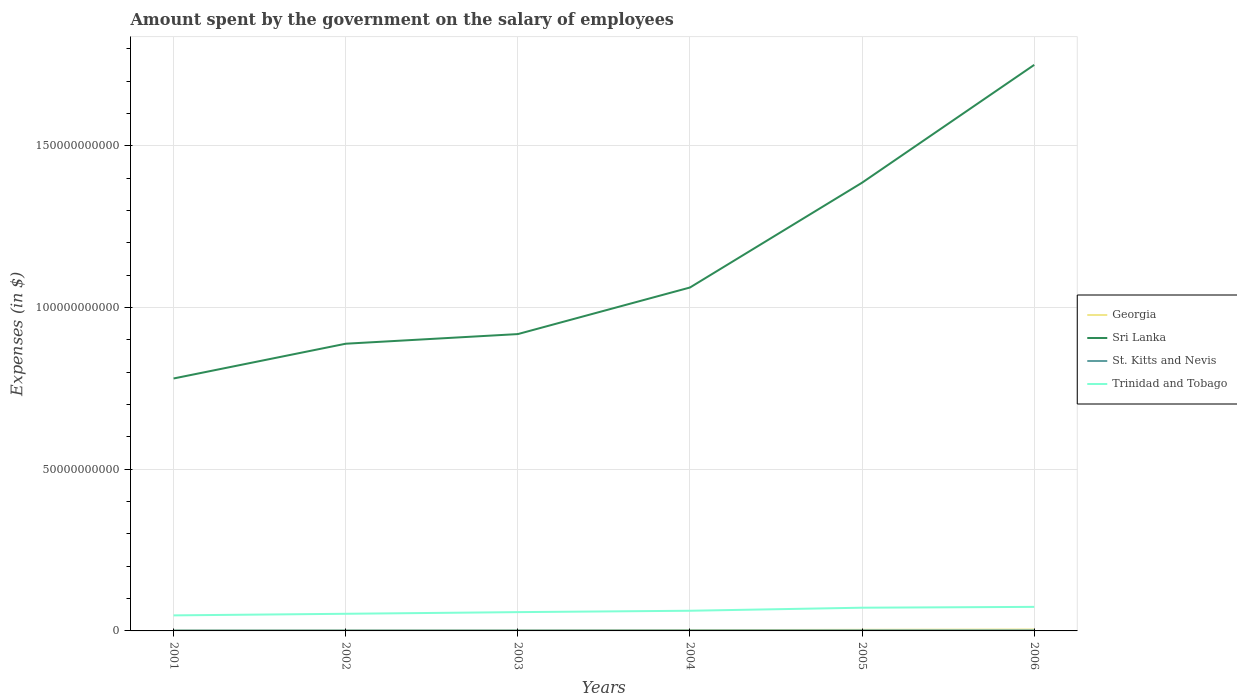Across all years, what is the maximum amount spent on the salary of employees by the government in Trinidad and Tobago?
Keep it short and to the point. 4.81e+09. What is the total amount spent on the salary of employees by the government in Sri Lanka in the graph?
Give a very brief answer. -4.98e+1. What is the difference between the highest and the second highest amount spent on the salary of employees by the government in Sri Lanka?
Your response must be concise. 9.70e+1. Is the amount spent on the salary of employees by the government in Sri Lanka strictly greater than the amount spent on the salary of employees by the government in Trinidad and Tobago over the years?
Make the answer very short. No. How many years are there in the graph?
Provide a short and direct response. 6. What is the title of the graph?
Make the answer very short. Amount spent by the government on the salary of employees. What is the label or title of the X-axis?
Your answer should be compact. Years. What is the label or title of the Y-axis?
Your answer should be compact. Expenses (in $). What is the Expenses (in $) of Georgia in 2001?
Ensure brevity in your answer.  9.74e+07. What is the Expenses (in $) in Sri Lanka in 2001?
Your answer should be very brief. 7.81e+1. What is the Expenses (in $) in St. Kitts and Nevis in 2001?
Give a very brief answer. 1.40e+08. What is the Expenses (in $) of Trinidad and Tobago in 2001?
Make the answer very short. 4.81e+09. What is the Expenses (in $) of Georgia in 2002?
Keep it short and to the point. 1.12e+08. What is the Expenses (in $) of Sri Lanka in 2002?
Provide a succinct answer. 8.88e+1. What is the Expenses (in $) of St. Kitts and Nevis in 2002?
Your response must be concise. 1.44e+08. What is the Expenses (in $) of Trinidad and Tobago in 2002?
Provide a succinct answer. 5.30e+09. What is the Expenses (in $) in Georgia in 2003?
Make the answer very short. 1.32e+08. What is the Expenses (in $) in Sri Lanka in 2003?
Ensure brevity in your answer.  9.18e+1. What is the Expenses (in $) of St. Kitts and Nevis in 2003?
Make the answer very short. 1.44e+08. What is the Expenses (in $) in Trinidad and Tobago in 2003?
Give a very brief answer. 5.81e+09. What is the Expenses (in $) in Georgia in 2004?
Your answer should be compact. 2.33e+08. What is the Expenses (in $) of Sri Lanka in 2004?
Make the answer very short. 1.06e+11. What is the Expenses (in $) in St. Kitts and Nevis in 2004?
Your response must be concise. 1.60e+08. What is the Expenses (in $) of Trinidad and Tobago in 2004?
Provide a short and direct response. 6.24e+09. What is the Expenses (in $) in Georgia in 2005?
Your response must be concise. 3.37e+08. What is the Expenses (in $) in Sri Lanka in 2005?
Ensure brevity in your answer.  1.39e+11. What is the Expenses (in $) of St. Kitts and Nevis in 2005?
Offer a terse response. 1.63e+08. What is the Expenses (in $) of Trinidad and Tobago in 2005?
Keep it short and to the point. 7.18e+09. What is the Expenses (in $) in Georgia in 2006?
Your answer should be very brief. 4.52e+08. What is the Expenses (in $) in Sri Lanka in 2006?
Ensure brevity in your answer.  1.75e+11. What is the Expenses (in $) of St. Kitts and Nevis in 2006?
Offer a terse response. 1.70e+08. What is the Expenses (in $) of Trinidad and Tobago in 2006?
Provide a short and direct response. 7.43e+09. Across all years, what is the maximum Expenses (in $) in Georgia?
Your answer should be compact. 4.52e+08. Across all years, what is the maximum Expenses (in $) of Sri Lanka?
Offer a terse response. 1.75e+11. Across all years, what is the maximum Expenses (in $) of St. Kitts and Nevis?
Provide a succinct answer. 1.70e+08. Across all years, what is the maximum Expenses (in $) of Trinidad and Tobago?
Your answer should be very brief. 7.43e+09. Across all years, what is the minimum Expenses (in $) in Georgia?
Offer a terse response. 9.74e+07. Across all years, what is the minimum Expenses (in $) in Sri Lanka?
Ensure brevity in your answer.  7.81e+1. Across all years, what is the minimum Expenses (in $) of St. Kitts and Nevis?
Your answer should be compact. 1.40e+08. Across all years, what is the minimum Expenses (in $) in Trinidad and Tobago?
Keep it short and to the point. 4.81e+09. What is the total Expenses (in $) in Georgia in the graph?
Offer a terse response. 1.36e+09. What is the total Expenses (in $) in Sri Lanka in the graph?
Your answer should be very brief. 6.78e+11. What is the total Expenses (in $) of St. Kitts and Nevis in the graph?
Offer a terse response. 9.21e+08. What is the total Expenses (in $) of Trinidad and Tobago in the graph?
Offer a terse response. 3.68e+1. What is the difference between the Expenses (in $) in Georgia in 2001 and that in 2002?
Ensure brevity in your answer.  -1.46e+07. What is the difference between the Expenses (in $) in Sri Lanka in 2001 and that in 2002?
Give a very brief answer. -1.07e+1. What is the difference between the Expenses (in $) of St. Kitts and Nevis in 2001 and that in 2002?
Offer a terse response. -3.90e+06. What is the difference between the Expenses (in $) in Trinidad and Tobago in 2001 and that in 2002?
Give a very brief answer. -4.90e+08. What is the difference between the Expenses (in $) of Georgia in 2001 and that in 2003?
Ensure brevity in your answer.  -3.41e+07. What is the difference between the Expenses (in $) of Sri Lanka in 2001 and that in 2003?
Keep it short and to the point. -1.37e+1. What is the difference between the Expenses (in $) of St. Kitts and Nevis in 2001 and that in 2003?
Give a very brief answer. -3.80e+06. What is the difference between the Expenses (in $) in Trinidad and Tobago in 2001 and that in 2003?
Make the answer very short. -1.00e+09. What is the difference between the Expenses (in $) of Georgia in 2001 and that in 2004?
Provide a short and direct response. -1.36e+08. What is the difference between the Expenses (in $) of Sri Lanka in 2001 and that in 2004?
Give a very brief answer. -2.81e+1. What is the difference between the Expenses (in $) in St. Kitts and Nevis in 2001 and that in 2004?
Your answer should be very brief. -1.94e+07. What is the difference between the Expenses (in $) in Trinidad and Tobago in 2001 and that in 2004?
Provide a succinct answer. -1.43e+09. What is the difference between the Expenses (in $) of Georgia in 2001 and that in 2005?
Keep it short and to the point. -2.39e+08. What is the difference between the Expenses (in $) in Sri Lanka in 2001 and that in 2005?
Your answer should be compact. -6.05e+1. What is the difference between the Expenses (in $) in St. Kitts and Nevis in 2001 and that in 2005?
Keep it short and to the point. -2.28e+07. What is the difference between the Expenses (in $) of Trinidad and Tobago in 2001 and that in 2005?
Make the answer very short. -2.37e+09. What is the difference between the Expenses (in $) of Georgia in 2001 and that in 2006?
Your answer should be very brief. -3.54e+08. What is the difference between the Expenses (in $) of Sri Lanka in 2001 and that in 2006?
Provide a short and direct response. -9.70e+1. What is the difference between the Expenses (in $) in St. Kitts and Nevis in 2001 and that in 2006?
Offer a very short reply. -2.92e+07. What is the difference between the Expenses (in $) in Trinidad and Tobago in 2001 and that in 2006?
Give a very brief answer. -2.63e+09. What is the difference between the Expenses (in $) of Georgia in 2002 and that in 2003?
Your response must be concise. -1.95e+07. What is the difference between the Expenses (in $) in Sri Lanka in 2002 and that in 2003?
Your answer should be very brief. -2.98e+09. What is the difference between the Expenses (in $) in Trinidad and Tobago in 2002 and that in 2003?
Your answer should be compact. -5.14e+08. What is the difference between the Expenses (in $) in Georgia in 2002 and that in 2004?
Make the answer very short. -1.21e+08. What is the difference between the Expenses (in $) in Sri Lanka in 2002 and that in 2004?
Give a very brief answer. -1.74e+1. What is the difference between the Expenses (in $) in St. Kitts and Nevis in 2002 and that in 2004?
Offer a terse response. -1.55e+07. What is the difference between the Expenses (in $) of Trinidad and Tobago in 2002 and that in 2004?
Your answer should be compact. -9.40e+08. What is the difference between the Expenses (in $) in Georgia in 2002 and that in 2005?
Your answer should be compact. -2.25e+08. What is the difference between the Expenses (in $) in Sri Lanka in 2002 and that in 2005?
Give a very brief answer. -4.98e+1. What is the difference between the Expenses (in $) of St. Kitts and Nevis in 2002 and that in 2005?
Keep it short and to the point. -1.89e+07. What is the difference between the Expenses (in $) in Trinidad and Tobago in 2002 and that in 2005?
Your answer should be compact. -1.88e+09. What is the difference between the Expenses (in $) in Georgia in 2002 and that in 2006?
Your answer should be compact. -3.40e+08. What is the difference between the Expenses (in $) in Sri Lanka in 2002 and that in 2006?
Keep it short and to the point. -8.62e+1. What is the difference between the Expenses (in $) in St. Kitts and Nevis in 2002 and that in 2006?
Your answer should be compact. -2.53e+07. What is the difference between the Expenses (in $) of Trinidad and Tobago in 2002 and that in 2006?
Offer a very short reply. -2.14e+09. What is the difference between the Expenses (in $) in Georgia in 2003 and that in 2004?
Ensure brevity in your answer.  -1.02e+08. What is the difference between the Expenses (in $) in Sri Lanka in 2003 and that in 2004?
Ensure brevity in your answer.  -1.44e+1. What is the difference between the Expenses (in $) of St. Kitts and Nevis in 2003 and that in 2004?
Your response must be concise. -1.56e+07. What is the difference between the Expenses (in $) of Trinidad and Tobago in 2003 and that in 2004?
Provide a succinct answer. -4.26e+08. What is the difference between the Expenses (in $) in Georgia in 2003 and that in 2005?
Provide a succinct answer. -2.05e+08. What is the difference between the Expenses (in $) in Sri Lanka in 2003 and that in 2005?
Give a very brief answer. -4.68e+1. What is the difference between the Expenses (in $) in St. Kitts and Nevis in 2003 and that in 2005?
Your answer should be very brief. -1.90e+07. What is the difference between the Expenses (in $) of Trinidad and Tobago in 2003 and that in 2005?
Your answer should be compact. -1.37e+09. What is the difference between the Expenses (in $) of Georgia in 2003 and that in 2006?
Keep it short and to the point. -3.20e+08. What is the difference between the Expenses (in $) in Sri Lanka in 2003 and that in 2006?
Offer a terse response. -8.32e+1. What is the difference between the Expenses (in $) in St. Kitts and Nevis in 2003 and that in 2006?
Your answer should be very brief. -2.54e+07. What is the difference between the Expenses (in $) in Trinidad and Tobago in 2003 and that in 2006?
Your answer should be compact. -1.62e+09. What is the difference between the Expenses (in $) of Georgia in 2004 and that in 2005?
Your answer should be compact. -1.04e+08. What is the difference between the Expenses (in $) in Sri Lanka in 2004 and that in 2005?
Provide a short and direct response. -3.24e+1. What is the difference between the Expenses (in $) of St. Kitts and Nevis in 2004 and that in 2005?
Your answer should be compact. -3.40e+06. What is the difference between the Expenses (in $) in Trinidad and Tobago in 2004 and that in 2005?
Your answer should be compact. -9.41e+08. What is the difference between the Expenses (in $) of Georgia in 2004 and that in 2006?
Provide a succinct answer. -2.18e+08. What is the difference between the Expenses (in $) in Sri Lanka in 2004 and that in 2006?
Make the answer very short. -6.88e+1. What is the difference between the Expenses (in $) in St. Kitts and Nevis in 2004 and that in 2006?
Offer a very short reply. -9.80e+06. What is the difference between the Expenses (in $) in Trinidad and Tobago in 2004 and that in 2006?
Provide a succinct answer. -1.20e+09. What is the difference between the Expenses (in $) in Georgia in 2005 and that in 2006?
Make the answer very short. -1.15e+08. What is the difference between the Expenses (in $) in Sri Lanka in 2005 and that in 2006?
Offer a very short reply. -3.64e+1. What is the difference between the Expenses (in $) of St. Kitts and Nevis in 2005 and that in 2006?
Provide a short and direct response. -6.40e+06. What is the difference between the Expenses (in $) of Trinidad and Tobago in 2005 and that in 2006?
Provide a succinct answer. -2.56e+08. What is the difference between the Expenses (in $) in Georgia in 2001 and the Expenses (in $) in Sri Lanka in 2002?
Your answer should be very brief. -8.87e+1. What is the difference between the Expenses (in $) of Georgia in 2001 and the Expenses (in $) of St. Kitts and Nevis in 2002?
Give a very brief answer. -4.68e+07. What is the difference between the Expenses (in $) in Georgia in 2001 and the Expenses (in $) in Trinidad and Tobago in 2002?
Provide a short and direct response. -5.20e+09. What is the difference between the Expenses (in $) of Sri Lanka in 2001 and the Expenses (in $) of St. Kitts and Nevis in 2002?
Your answer should be compact. 7.79e+1. What is the difference between the Expenses (in $) in Sri Lanka in 2001 and the Expenses (in $) in Trinidad and Tobago in 2002?
Offer a terse response. 7.28e+1. What is the difference between the Expenses (in $) of St. Kitts and Nevis in 2001 and the Expenses (in $) of Trinidad and Tobago in 2002?
Offer a terse response. -5.16e+09. What is the difference between the Expenses (in $) of Georgia in 2001 and the Expenses (in $) of Sri Lanka in 2003?
Your answer should be very brief. -9.17e+1. What is the difference between the Expenses (in $) of Georgia in 2001 and the Expenses (in $) of St. Kitts and Nevis in 2003?
Offer a terse response. -4.67e+07. What is the difference between the Expenses (in $) in Georgia in 2001 and the Expenses (in $) in Trinidad and Tobago in 2003?
Ensure brevity in your answer.  -5.71e+09. What is the difference between the Expenses (in $) of Sri Lanka in 2001 and the Expenses (in $) of St. Kitts and Nevis in 2003?
Provide a short and direct response. 7.79e+1. What is the difference between the Expenses (in $) in Sri Lanka in 2001 and the Expenses (in $) in Trinidad and Tobago in 2003?
Offer a terse response. 7.22e+1. What is the difference between the Expenses (in $) of St. Kitts and Nevis in 2001 and the Expenses (in $) of Trinidad and Tobago in 2003?
Provide a short and direct response. -5.67e+09. What is the difference between the Expenses (in $) in Georgia in 2001 and the Expenses (in $) in Sri Lanka in 2004?
Offer a terse response. -1.06e+11. What is the difference between the Expenses (in $) in Georgia in 2001 and the Expenses (in $) in St. Kitts and Nevis in 2004?
Make the answer very short. -6.23e+07. What is the difference between the Expenses (in $) of Georgia in 2001 and the Expenses (in $) of Trinidad and Tobago in 2004?
Give a very brief answer. -6.14e+09. What is the difference between the Expenses (in $) in Sri Lanka in 2001 and the Expenses (in $) in St. Kitts and Nevis in 2004?
Provide a short and direct response. 7.79e+1. What is the difference between the Expenses (in $) in Sri Lanka in 2001 and the Expenses (in $) in Trinidad and Tobago in 2004?
Offer a very short reply. 7.18e+1. What is the difference between the Expenses (in $) in St. Kitts and Nevis in 2001 and the Expenses (in $) in Trinidad and Tobago in 2004?
Provide a short and direct response. -6.10e+09. What is the difference between the Expenses (in $) of Georgia in 2001 and the Expenses (in $) of Sri Lanka in 2005?
Provide a succinct answer. -1.39e+11. What is the difference between the Expenses (in $) of Georgia in 2001 and the Expenses (in $) of St. Kitts and Nevis in 2005?
Your answer should be very brief. -6.57e+07. What is the difference between the Expenses (in $) of Georgia in 2001 and the Expenses (in $) of Trinidad and Tobago in 2005?
Ensure brevity in your answer.  -7.08e+09. What is the difference between the Expenses (in $) in Sri Lanka in 2001 and the Expenses (in $) in St. Kitts and Nevis in 2005?
Your response must be concise. 7.79e+1. What is the difference between the Expenses (in $) in Sri Lanka in 2001 and the Expenses (in $) in Trinidad and Tobago in 2005?
Your answer should be very brief. 7.09e+1. What is the difference between the Expenses (in $) in St. Kitts and Nevis in 2001 and the Expenses (in $) in Trinidad and Tobago in 2005?
Ensure brevity in your answer.  -7.04e+09. What is the difference between the Expenses (in $) in Georgia in 2001 and the Expenses (in $) in Sri Lanka in 2006?
Provide a short and direct response. -1.75e+11. What is the difference between the Expenses (in $) of Georgia in 2001 and the Expenses (in $) of St. Kitts and Nevis in 2006?
Your answer should be compact. -7.21e+07. What is the difference between the Expenses (in $) in Georgia in 2001 and the Expenses (in $) in Trinidad and Tobago in 2006?
Offer a terse response. -7.34e+09. What is the difference between the Expenses (in $) of Sri Lanka in 2001 and the Expenses (in $) of St. Kitts and Nevis in 2006?
Your answer should be compact. 7.79e+1. What is the difference between the Expenses (in $) of Sri Lanka in 2001 and the Expenses (in $) of Trinidad and Tobago in 2006?
Offer a very short reply. 7.06e+1. What is the difference between the Expenses (in $) of St. Kitts and Nevis in 2001 and the Expenses (in $) of Trinidad and Tobago in 2006?
Your answer should be very brief. -7.29e+09. What is the difference between the Expenses (in $) in Georgia in 2002 and the Expenses (in $) in Sri Lanka in 2003?
Give a very brief answer. -9.17e+1. What is the difference between the Expenses (in $) in Georgia in 2002 and the Expenses (in $) in St. Kitts and Nevis in 2003?
Offer a very short reply. -3.21e+07. What is the difference between the Expenses (in $) of Georgia in 2002 and the Expenses (in $) of Trinidad and Tobago in 2003?
Provide a succinct answer. -5.70e+09. What is the difference between the Expenses (in $) in Sri Lanka in 2002 and the Expenses (in $) in St. Kitts and Nevis in 2003?
Ensure brevity in your answer.  8.87e+1. What is the difference between the Expenses (in $) in Sri Lanka in 2002 and the Expenses (in $) in Trinidad and Tobago in 2003?
Ensure brevity in your answer.  8.30e+1. What is the difference between the Expenses (in $) in St. Kitts and Nevis in 2002 and the Expenses (in $) in Trinidad and Tobago in 2003?
Offer a terse response. -5.67e+09. What is the difference between the Expenses (in $) of Georgia in 2002 and the Expenses (in $) of Sri Lanka in 2004?
Ensure brevity in your answer.  -1.06e+11. What is the difference between the Expenses (in $) of Georgia in 2002 and the Expenses (in $) of St. Kitts and Nevis in 2004?
Ensure brevity in your answer.  -4.77e+07. What is the difference between the Expenses (in $) in Georgia in 2002 and the Expenses (in $) in Trinidad and Tobago in 2004?
Your response must be concise. -6.13e+09. What is the difference between the Expenses (in $) in Sri Lanka in 2002 and the Expenses (in $) in St. Kitts and Nevis in 2004?
Your response must be concise. 8.86e+1. What is the difference between the Expenses (in $) in Sri Lanka in 2002 and the Expenses (in $) in Trinidad and Tobago in 2004?
Provide a short and direct response. 8.26e+1. What is the difference between the Expenses (in $) in St. Kitts and Nevis in 2002 and the Expenses (in $) in Trinidad and Tobago in 2004?
Provide a succinct answer. -6.09e+09. What is the difference between the Expenses (in $) of Georgia in 2002 and the Expenses (in $) of Sri Lanka in 2005?
Keep it short and to the point. -1.38e+11. What is the difference between the Expenses (in $) in Georgia in 2002 and the Expenses (in $) in St. Kitts and Nevis in 2005?
Offer a very short reply. -5.11e+07. What is the difference between the Expenses (in $) of Georgia in 2002 and the Expenses (in $) of Trinidad and Tobago in 2005?
Offer a terse response. -7.07e+09. What is the difference between the Expenses (in $) in Sri Lanka in 2002 and the Expenses (in $) in St. Kitts and Nevis in 2005?
Your answer should be very brief. 8.86e+1. What is the difference between the Expenses (in $) of Sri Lanka in 2002 and the Expenses (in $) of Trinidad and Tobago in 2005?
Give a very brief answer. 8.16e+1. What is the difference between the Expenses (in $) of St. Kitts and Nevis in 2002 and the Expenses (in $) of Trinidad and Tobago in 2005?
Provide a succinct answer. -7.04e+09. What is the difference between the Expenses (in $) in Georgia in 2002 and the Expenses (in $) in Sri Lanka in 2006?
Your answer should be very brief. -1.75e+11. What is the difference between the Expenses (in $) in Georgia in 2002 and the Expenses (in $) in St. Kitts and Nevis in 2006?
Give a very brief answer. -5.75e+07. What is the difference between the Expenses (in $) of Georgia in 2002 and the Expenses (in $) of Trinidad and Tobago in 2006?
Provide a short and direct response. -7.32e+09. What is the difference between the Expenses (in $) of Sri Lanka in 2002 and the Expenses (in $) of St. Kitts and Nevis in 2006?
Your answer should be compact. 8.86e+1. What is the difference between the Expenses (in $) in Sri Lanka in 2002 and the Expenses (in $) in Trinidad and Tobago in 2006?
Keep it short and to the point. 8.14e+1. What is the difference between the Expenses (in $) in St. Kitts and Nevis in 2002 and the Expenses (in $) in Trinidad and Tobago in 2006?
Your response must be concise. -7.29e+09. What is the difference between the Expenses (in $) of Georgia in 2003 and the Expenses (in $) of Sri Lanka in 2004?
Provide a succinct answer. -1.06e+11. What is the difference between the Expenses (in $) in Georgia in 2003 and the Expenses (in $) in St. Kitts and Nevis in 2004?
Your response must be concise. -2.82e+07. What is the difference between the Expenses (in $) in Georgia in 2003 and the Expenses (in $) in Trinidad and Tobago in 2004?
Ensure brevity in your answer.  -6.11e+09. What is the difference between the Expenses (in $) in Sri Lanka in 2003 and the Expenses (in $) in St. Kitts and Nevis in 2004?
Your response must be concise. 9.16e+1. What is the difference between the Expenses (in $) of Sri Lanka in 2003 and the Expenses (in $) of Trinidad and Tobago in 2004?
Give a very brief answer. 8.55e+1. What is the difference between the Expenses (in $) of St. Kitts and Nevis in 2003 and the Expenses (in $) of Trinidad and Tobago in 2004?
Your response must be concise. -6.09e+09. What is the difference between the Expenses (in $) of Georgia in 2003 and the Expenses (in $) of Sri Lanka in 2005?
Provide a short and direct response. -1.38e+11. What is the difference between the Expenses (in $) of Georgia in 2003 and the Expenses (in $) of St. Kitts and Nevis in 2005?
Your answer should be very brief. -3.16e+07. What is the difference between the Expenses (in $) of Georgia in 2003 and the Expenses (in $) of Trinidad and Tobago in 2005?
Your answer should be compact. -7.05e+09. What is the difference between the Expenses (in $) of Sri Lanka in 2003 and the Expenses (in $) of St. Kitts and Nevis in 2005?
Your answer should be very brief. 9.16e+1. What is the difference between the Expenses (in $) of Sri Lanka in 2003 and the Expenses (in $) of Trinidad and Tobago in 2005?
Your answer should be very brief. 8.46e+1. What is the difference between the Expenses (in $) of St. Kitts and Nevis in 2003 and the Expenses (in $) of Trinidad and Tobago in 2005?
Your answer should be very brief. -7.04e+09. What is the difference between the Expenses (in $) of Georgia in 2003 and the Expenses (in $) of Sri Lanka in 2006?
Your answer should be very brief. -1.75e+11. What is the difference between the Expenses (in $) in Georgia in 2003 and the Expenses (in $) in St. Kitts and Nevis in 2006?
Offer a very short reply. -3.80e+07. What is the difference between the Expenses (in $) in Georgia in 2003 and the Expenses (in $) in Trinidad and Tobago in 2006?
Provide a short and direct response. -7.30e+09. What is the difference between the Expenses (in $) of Sri Lanka in 2003 and the Expenses (in $) of St. Kitts and Nevis in 2006?
Offer a terse response. 9.16e+1. What is the difference between the Expenses (in $) in Sri Lanka in 2003 and the Expenses (in $) in Trinidad and Tobago in 2006?
Your response must be concise. 8.43e+1. What is the difference between the Expenses (in $) of St. Kitts and Nevis in 2003 and the Expenses (in $) of Trinidad and Tobago in 2006?
Your answer should be compact. -7.29e+09. What is the difference between the Expenses (in $) in Georgia in 2004 and the Expenses (in $) in Sri Lanka in 2005?
Your answer should be very brief. -1.38e+11. What is the difference between the Expenses (in $) of Georgia in 2004 and the Expenses (in $) of St. Kitts and Nevis in 2005?
Provide a succinct answer. 6.99e+07. What is the difference between the Expenses (in $) of Georgia in 2004 and the Expenses (in $) of Trinidad and Tobago in 2005?
Your answer should be very brief. -6.95e+09. What is the difference between the Expenses (in $) of Sri Lanka in 2004 and the Expenses (in $) of St. Kitts and Nevis in 2005?
Your answer should be compact. 1.06e+11. What is the difference between the Expenses (in $) of Sri Lanka in 2004 and the Expenses (in $) of Trinidad and Tobago in 2005?
Provide a succinct answer. 9.90e+1. What is the difference between the Expenses (in $) of St. Kitts and Nevis in 2004 and the Expenses (in $) of Trinidad and Tobago in 2005?
Offer a very short reply. -7.02e+09. What is the difference between the Expenses (in $) in Georgia in 2004 and the Expenses (in $) in Sri Lanka in 2006?
Your answer should be very brief. -1.75e+11. What is the difference between the Expenses (in $) of Georgia in 2004 and the Expenses (in $) of St. Kitts and Nevis in 2006?
Give a very brief answer. 6.35e+07. What is the difference between the Expenses (in $) of Georgia in 2004 and the Expenses (in $) of Trinidad and Tobago in 2006?
Offer a terse response. -7.20e+09. What is the difference between the Expenses (in $) in Sri Lanka in 2004 and the Expenses (in $) in St. Kitts and Nevis in 2006?
Make the answer very short. 1.06e+11. What is the difference between the Expenses (in $) in Sri Lanka in 2004 and the Expenses (in $) in Trinidad and Tobago in 2006?
Keep it short and to the point. 9.88e+1. What is the difference between the Expenses (in $) in St. Kitts and Nevis in 2004 and the Expenses (in $) in Trinidad and Tobago in 2006?
Offer a terse response. -7.28e+09. What is the difference between the Expenses (in $) of Georgia in 2005 and the Expenses (in $) of Sri Lanka in 2006?
Your response must be concise. -1.75e+11. What is the difference between the Expenses (in $) of Georgia in 2005 and the Expenses (in $) of St. Kitts and Nevis in 2006?
Ensure brevity in your answer.  1.67e+08. What is the difference between the Expenses (in $) in Georgia in 2005 and the Expenses (in $) in Trinidad and Tobago in 2006?
Provide a short and direct response. -7.10e+09. What is the difference between the Expenses (in $) in Sri Lanka in 2005 and the Expenses (in $) in St. Kitts and Nevis in 2006?
Give a very brief answer. 1.38e+11. What is the difference between the Expenses (in $) in Sri Lanka in 2005 and the Expenses (in $) in Trinidad and Tobago in 2006?
Make the answer very short. 1.31e+11. What is the difference between the Expenses (in $) in St. Kitts and Nevis in 2005 and the Expenses (in $) in Trinidad and Tobago in 2006?
Offer a terse response. -7.27e+09. What is the average Expenses (in $) in Georgia per year?
Your answer should be very brief. 2.27e+08. What is the average Expenses (in $) of Sri Lanka per year?
Offer a terse response. 1.13e+11. What is the average Expenses (in $) of St. Kitts and Nevis per year?
Provide a short and direct response. 1.53e+08. What is the average Expenses (in $) of Trinidad and Tobago per year?
Give a very brief answer. 6.13e+09. In the year 2001, what is the difference between the Expenses (in $) in Georgia and Expenses (in $) in Sri Lanka?
Offer a terse response. -7.80e+1. In the year 2001, what is the difference between the Expenses (in $) of Georgia and Expenses (in $) of St. Kitts and Nevis?
Ensure brevity in your answer.  -4.29e+07. In the year 2001, what is the difference between the Expenses (in $) of Georgia and Expenses (in $) of Trinidad and Tobago?
Make the answer very short. -4.71e+09. In the year 2001, what is the difference between the Expenses (in $) in Sri Lanka and Expenses (in $) in St. Kitts and Nevis?
Offer a very short reply. 7.79e+1. In the year 2001, what is the difference between the Expenses (in $) of Sri Lanka and Expenses (in $) of Trinidad and Tobago?
Give a very brief answer. 7.32e+1. In the year 2001, what is the difference between the Expenses (in $) in St. Kitts and Nevis and Expenses (in $) in Trinidad and Tobago?
Ensure brevity in your answer.  -4.67e+09. In the year 2002, what is the difference between the Expenses (in $) of Georgia and Expenses (in $) of Sri Lanka?
Make the answer very short. -8.87e+1. In the year 2002, what is the difference between the Expenses (in $) of Georgia and Expenses (in $) of St. Kitts and Nevis?
Provide a succinct answer. -3.22e+07. In the year 2002, what is the difference between the Expenses (in $) in Georgia and Expenses (in $) in Trinidad and Tobago?
Offer a very short reply. -5.19e+09. In the year 2002, what is the difference between the Expenses (in $) of Sri Lanka and Expenses (in $) of St. Kitts and Nevis?
Keep it short and to the point. 8.87e+1. In the year 2002, what is the difference between the Expenses (in $) of Sri Lanka and Expenses (in $) of Trinidad and Tobago?
Your answer should be very brief. 8.35e+1. In the year 2002, what is the difference between the Expenses (in $) of St. Kitts and Nevis and Expenses (in $) of Trinidad and Tobago?
Provide a short and direct response. -5.15e+09. In the year 2003, what is the difference between the Expenses (in $) of Georgia and Expenses (in $) of Sri Lanka?
Give a very brief answer. -9.17e+1. In the year 2003, what is the difference between the Expenses (in $) of Georgia and Expenses (in $) of St. Kitts and Nevis?
Your answer should be very brief. -1.26e+07. In the year 2003, what is the difference between the Expenses (in $) of Georgia and Expenses (in $) of Trinidad and Tobago?
Make the answer very short. -5.68e+09. In the year 2003, what is the difference between the Expenses (in $) of Sri Lanka and Expenses (in $) of St. Kitts and Nevis?
Provide a succinct answer. 9.16e+1. In the year 2003, what is the difference between the Expenses (in $) of Sri Lanka and Expenses (in $) of Trinidad and Tobago?
Ensure brevity in your answer.  8.60e+1. In the year 2003, what is the difference between the Expenses (in $) of St. Kitts and Nevis and Expenses (in $) of Trinidad and Tobago?
Your response must be concise. -5.67e+09. In the year 2004, what is the difference between the Expenses (in $) in Georgia and Expenses (in $) in Sri Lanka?
Ensure brevity in your answer.  -1.06e+11. In the year 2004, what is the difference between the Expenses (in $) of Georgia and Expenses (in $) of St. Kitts and Nevis?
Offer a very short reply. 7.33e+07. In the year 2004, what is the difference between the Expenses (in $) of Georgia and Expenses (in $) of Trinidad and Tobago?
Keep it short and to the point. -6.01e+09. In the year 2004, what is the difference between the Expenses (in $) in Sri Lanka and Expenses (in $) in St. Kitts and Nevis?
Keep it short and to the point. 1.06e+11. In the year 2004, what is the difference between the Expenses (in $) of Sri Lanka and Expenses (in $) of Trinidad and Tobago?
Your answer should be compact. 9.99e+1. In the year 2004, what is the difference between the Expenses (in $) in St. Kitts and Nevis and Expenses (in $) in Trinidad and Tobago?
Provide a short and direct response. -6.08e+09. In the year 2005, what is the difference between the Expenses (in $) of Georgia and Expenses (in $) of Sri Lanka?
Your response must be concise. -1.38e+11. In the year 2005, what is the difference between the Expenses (in $) of Georgia and Expenses (in $) of St. Kitts and Nevis?
Keep it short and to the point. 1.74e+08. In the year 2005, what is the difference between the Expenses (in $) of Georgia and Expenses (in $) of Trinidad and Tobago?
Provide a succinct answer. -6.84e+09. In the year 2005, what is the difference between the Expenses (in $) in Sri Lanka and Expenses (in $) in St. Kitts and Nevis?
Offer a terse response. 1.38e+11. In the year 2005, what is the difference between the Expenses (in $) of Sri Lanka and Expenses (in $) of Trinidad and Tobago?
Offer a very short reply. 1.31e+11. In the year 2005, what is the difference between the Expenses (in $) of St. Kitts and Nevis and Expenses (in $) of Trinidad and Tobago?
Offer a very short reply. -7.02e+09. In the year 2006, what is the difference between the Expenses (in $) of Georgia and Expenses (in $) of Sri Lanka?
Your answer should be compact. -1.75e+11. In the year 2006, what is the difference between the Expenses (in $) of Georgia and Expenses (in $) of St. Kitts and Nevis?
Keep it short and to the point. 2.82e+08. In the year 2006, what is the difference between the Expenses (in $) in Georgia and Expenses (in $) in Trinidad and Tobago?
Ensure brevity in your answer.  -6.98e+09. In the year 2006, what is the difference between the Expenses (in $) of Sri Lanka and Expenses (in $) of St. Kitts and Nevis?
Keep it short and to the point. 1.75e+11. In the year 2006, what is the difference between the Expenses (in $) of Sri Lanka and Expenses (in $) of Trinidad and Tobago?
Your answer should be very brief. 1.68e+11. In the year 2006, what is the difference between the Expenses (in $) in St. Kitts and Nevis and Expenses (in $) in Trinidad and Tobago?
Ensure brevity in your answer.  -7.27e+09. What is the ratio of the Expenses (in $) in Georgia in 2001 to that in 2002?
Your answer should be very brief. 0.87. What is the ratio of the Expenses (in $) in Sri Lanka in 2001 to that in 2002?
Keep it short and to the point. 0.88. What is the ratio of the Expenses (in $) of St. Kitts and Nevis in 2001 to that in 2002?
Provide a short and direct response. 0.97. What is the ratio of the Expenses (in $) of Trinidad and Tobago in 2001 to that in 2002?
Your answer should be very brief. 0.91. What is the ratio of the Expenses (in $) in Georgia in 2001 to that in 2003?
Provide a succinct answer. 0.74. What is the ratio of the Expenses (in $) of Sri Lanka in 2001 to that in 2003?
Keep it short and to the point. 0.85. What is the ratio of the Expenses (in $) in St. Kitts and Nevis in 2001 to that in 2003?
Provide a succinct answer. 0.97. What is the ratio of the Expenses (in $) in Trinidad and Tobago in 2001 to that in 2003?
Ensure brevity in your answer.  0.83. What is the ratio of the Expenses (in $) in Georgia in 2001 to that in 2004?
Make the answer very short. 0.42. What is the ratio of the Expenses (in $) of Sri Lanka in 2001 to that in 2004?
Your response must be concise. 0.74. What is the ratio of the Expenses (in $) in St. Kitts and Nevis in 2001 to that in 2004?
Make the answer very short. 0.88. What is the ratio of the Expenses (in $) in Trinidad and Tobago in 2001 to that in 2004?
Offer a very short reply. 0.77. What is the ratio of the Expenses (in $) of Georgia in 2001 to that in 2005?
Your answer should be very brief. 0.29. What is the ratio of the Expenses (in $) of Sri Lanka in 2001 to that in 2005?
Offer a terse response. 0.56. What is the ratio of the Expenses (in $) in St. Kitts and Nevis in 2001 to that in 2005?
Your answer should be very brief. 0.86. What is the ratio of the Expenses (in $) in Trinidad and Tobago in 2001 to that in 2005?
Keep it short and to the point. 0.67. What is the ratio of the Expenses (in $) of Georgia in 2001 to that in 2006?
Provide a short and direct response. 0.22. What is the ratio of the Expenses (in $) of Sri Lanka in 2001 to that in 2006?
Ensure brevity in your answer.  0.45. What is the ratio of the Expenses (in $) of St. Kitts and Nevis in 2001 to that in 2006?
Make the answer very short. 0.83. What is the ratio of the Expenses (in $) in Trinidad and Tobago in 2001 to that in 2006?
Your answer should be very brief. 0.65. What is the ratio of the Expenses (in $) of Georgia in 2002 to that in 2003?
Your answer should be compact. 0.85. What is the ratio of the Expenses (in $) of Sri Lanka in 2002 to that in 2003?
Keep it short and to the point. 0.97. What is the ratio of the Expenses (in $) of St. Kitts and Nevis in 2002 to that in 2003?
Provide a short and direct response. 1. What is the ratio of the Expenses (in $) in Trinidad and Tobago in 2002 to that in 2003?
Offer a terse response. 0.91. What is the ratio of the Expenses (in $) in Georgia in 2002 to that in 2004?
Your answer should be very brief. 0.48. What is the ratio of the Expenses (in $) in Sri Lanka in 2002 to that in 2004?
Keep it short and to the point. 0.84. What is the ratio of the Expenses (in $) of St. Kitts and Nevis in 2002 to that in 2004?
Offer a very short reply. 0.9. What is the ratio of the Expenses (in $) in Trinidad and Tobago in 2002 to that in 2004?
Give a very brief answer. 0.85. What is the ratio of the Expenses (in $) in Georgia in 2002 to that in 2005?
Keep it short and to the point. 0.33. What is the ratio of the Expenses (in $) of Sri Lanka in 2002 to that in 2005?
Your answer should be very brief. 0.64. What is the ratio of the Expenses (in $) in St. Kitts and Nevis in 2002 to that in 2005?
Provide a short and direct response. 0.88. What is the ratio of the Expenses (in $) of Trinidad and Tobago in 2002 to that in 2005?
Your answer should be compact. 0.74. What is the ratio of the Expenses (in $) of Georgia in 2002 to that in 2006?
Give a very brief answer. 0.25. What is the ratio of the Expenses (in $) of Sri Lanka in 2002 to that in 2006?
Provide a short and direct response. 0.51. What is the ratio of the Expenses (in $) in St. Kitts and Nevis in 2002 to that in 2006?
Offer a very short reply. 0.85. What is the ratio of the Expenses (in $) in Trinidad and Tobago in 2002 to that in 2006?
Keep it short and to the point. 0.71. What is the ratio of the Expenses (in $) in Georgia in 2003 to that in 2004?
Offer a terse response. 0.56. What is the ratio of the Expenses (in $) of Sri Lanka in 2003 to that in 2004?
Provide a short and direct response. 0.86. What is the ratio of the Expenses (in $) of St. Kitts and Nevis in 2003 to that in 2004?
Give a very brief answer. 0.9. What is the ratio of the Expenses (in $) of Trinidad and Tobago in 2003 to that in 2004?
Your answer should be very brief. 0.93. What is the ratio of the Expenses (in $) of Georgia in 2003 to that in 2005?
Make the answer very short. 0.39. What is the ratio of the Expenses (in $) in Sri Lanka in 2003 to that in 2005?
Your answer should be very brief. 0.66. What is the ratio of the Expenses (in $) of St. Kitts and Nevis in 2003 to that in 2005?
Make the answer very short. 0.88. What is the ratio of the Expenses (in $) of Trinidad and Tobago in 2003 to that in 2005?
Your answer should be compact. 0.81. What is the ratio of the Expenses (in $) of Georgia in 2003 to that in 2006?
Give a very brief answer. 0.29. What is the ratio of the Expenses (in $) of Sri Lanka in 2003 to that in 2006?
Provide a succinct answer. 0.52. What is the ratio of the Expenses (in $) of St. Kitts and Nevis in 2003 to that in 2006?
Ensure brevity in your answer.  0.85. What is the ratio of the Expenses (in $) of Trinidad and Tobago in 2003 to that in 2006?
Give a very brief answer. 0.78. What is the ratio of the Expenses (in $) of Georgia in 2004 to that in 2005?
Your answer should be compact. 0.69. What is the ratio of the Expenses (in $) in Sri Lanka in 2004 to that in 2005?
Give a very brief answer. 0.77. What is the ratio of the Expenses (in $) of St. Kitts and Nevis in 2004 to that in 2005?
Make the answer very short. 0.98. What is the ratio of the Expenses (in $) in Trinidad and Tobago in 2004 to that in 2005?
Offer a terse response. 0.87. What is the ratio of the Expenses (in $) in Georgia in 2004 to that in 2006?
Your answer should be very brief. 0.52. What is the ratio of the Expenses (in $) in Sri Lanka in 2004 to that in 2006?
Your answer should be very brief. 0.61. What is the ratio of the Expenses (in $) of St. Kitts and Nevis in 2004 to that in 2006?
Keep it short and to the point. 0.94. What is the ratio of the Expenses (in $) of Trinidad and Tobago in 2004 to that in 2006?
Provide a succinct answer. 0.84. What is the ratio of the Expenses (in $) in Georgia in 2005 to that in 2006?
Your answer should be very brief. 0.75. What is the ratio of the Expenses (in $) in Sri Lanka in 2005 to that in 2006?
Offer a terse response. 0.79. What is the ratio of the Expenses (in $) of St. Kitts and Nevis in 2005 to that in 2006?
Your answer should be very brief. 0.96. What is the ratio of the Expenses (in $) of Trinidad and Tobago in 2005 to that in 2006?
Offer a very short reply. 0.97. What is the difference between the highest and the second highest Expenses (in $) of Georgia?
Provide a succinct answer. 1.15e+08. What is the difference between the highest and the second highest Expenses (in $) in Sri Lanka?
Provide a succinct answer. 3.64e+1. What is the difference between the highest and the second highest Expenses (in $) of St. Kitts and Nevis?
Your response must be concise. 6.40e+06. What is the difference between the highest and the second highest Expenses (in $) of Trinidad and Tobago?
Offer a very short reply. 2.56e+08. What is the difference between the highest and the lowest Expenses (in $) of Georgia?
Your answer should be very brief. 3.54e+08. What is the difference between the highest and the lowest Expenses (in $) of Sri Lanka?
Ensure brevity in your answer.  9.70e+1. What is the difference between the highest and the lowest Expenses (in $) of St. Kitts and Nevis?
Give a very brief answer. 2.92e+07. What is the difference between the highest and the lowest Expenses (in $) of Trinidad and Tobago?
Offer a terse response. 2.63e+09. 